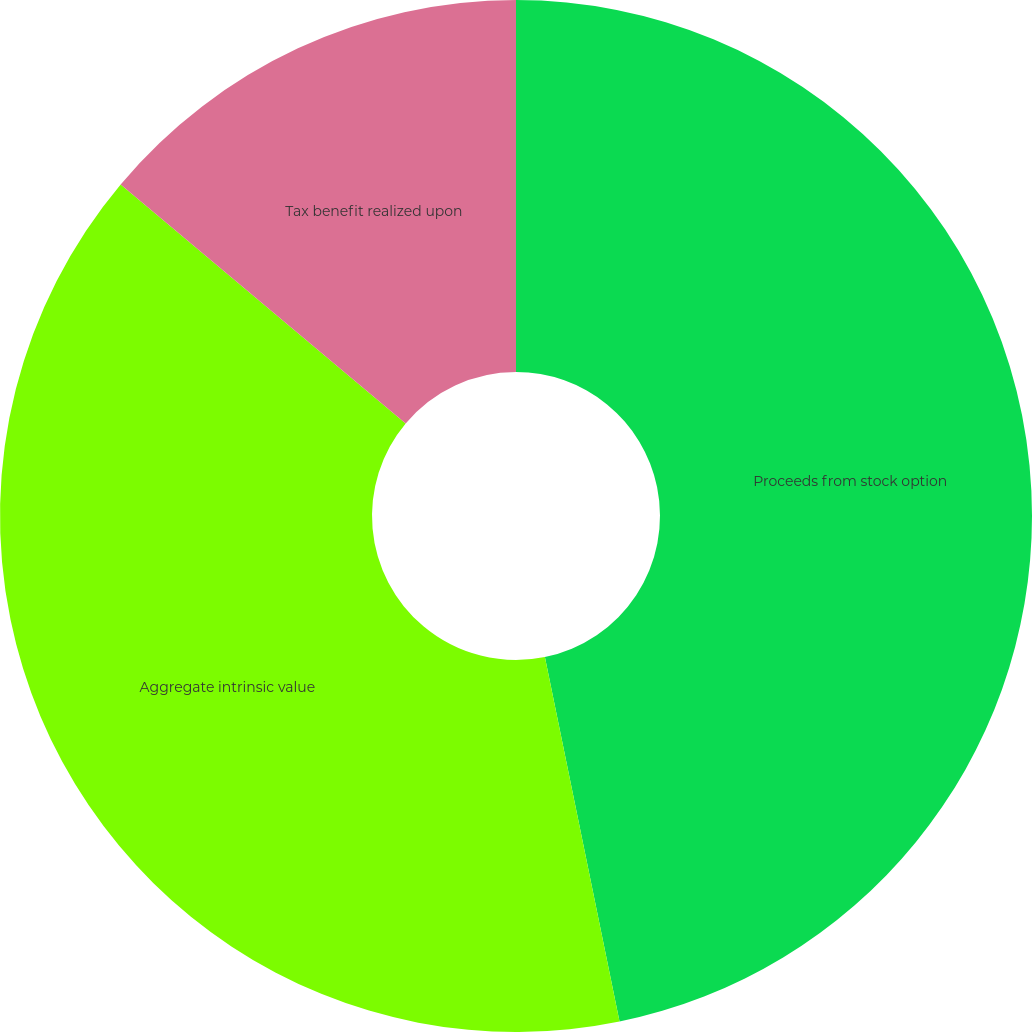Convert chart to OTSL. <chart><loc_0><loc_0><loc_500><loc_500><pie_chart><fcel>Proceeds from stock option<fcel>Aggregate intrinsic value<fcel>Tax benefit realized upon<nl><fcel>46.78%<fcel>39.32%<fcel>13.89%<nl></chart> 